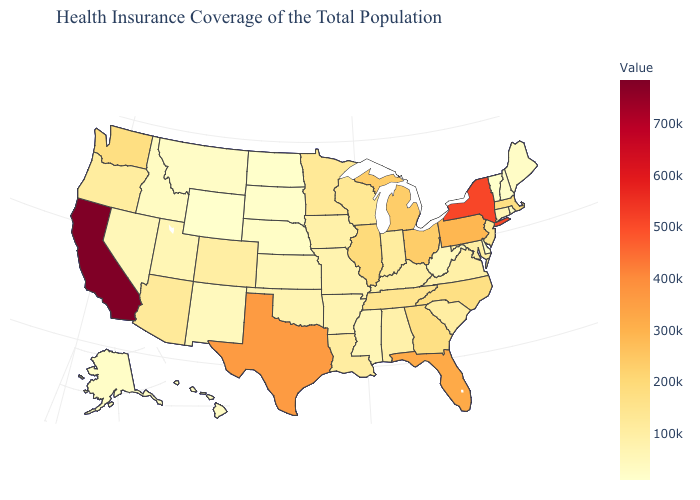Among the states that border Montana , which have the highest value?
Quick response, please. Idaho. Which states hav the highest value in the West?
Write a very short answer. California. Among the states that border Nevada , which have the lowest value?
Short answer required. Idaho. Among the states that border Georgia , which have the lowest value?
Write a very short answer. Alabama. Which states have the lowest value in the MidWest?
Quick response, please. North Dakota. 